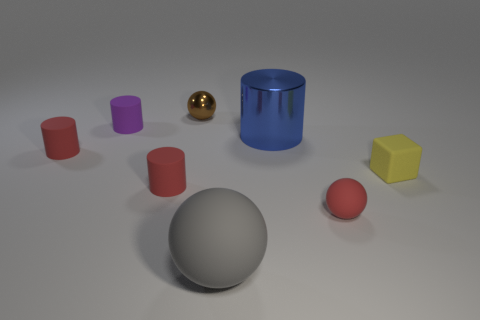What is the color of the small shiny ball?
Offer a terse response. Brown. What is the shape of the thing that is in front of the red object that is right of the cylinder to the right of the tiny brown thing?
Your response must be concise. Sphere. What is the material of the object that is in front of the large cylinder and behind the tiny yellow rubber thing?
Offer a terse response. Rubber. There is a red object that is to the right of the shiny object that is to the left of the blue metal cylinder; what shape is it?
Make the answer very short. Sphere. Is there any other thing that has the same color as the shiny cylinder?
Your answer should be compact. No. Is the size of the brown object the same as the matte thing that is left of the purple matte object?
Keep it short and to the point. Yes. How many big objects are gray things or yellow metallic balls?
Keep it short and to the point. 1. Is the number of blue cylinders greater than the number of big yellow shiny cubes?
Your response must be concise. Yes. What number of tiny things are to the right of the small purple matte cylinder that is to the left of the red object that is right of the tiny brown object?
Provide a succinct answer. 4. There is a blue shiny thing; what shape is it?
Make the answer very short. Cylinder. 